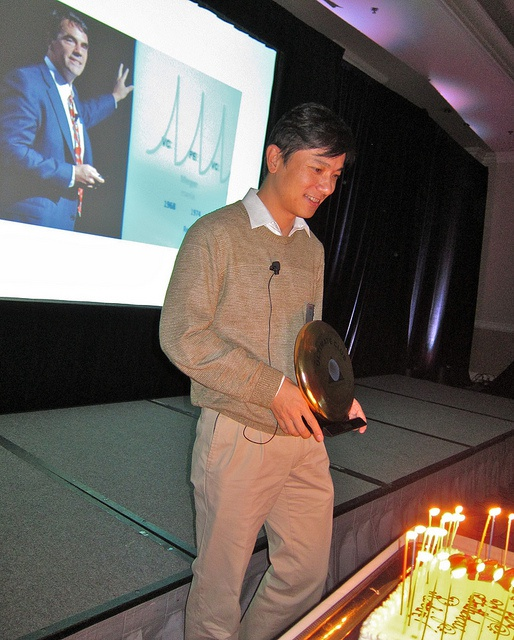Describe the objects in this image and their specific colors. I can see people in gray, tan, and salmon tones, cake in gray, khaki, ivory, and red tones, frisbee in gray, black, maroon, and brown tones, and tie in gray, lightpink, lightgray, darkgray, and salmon tones in this image. 